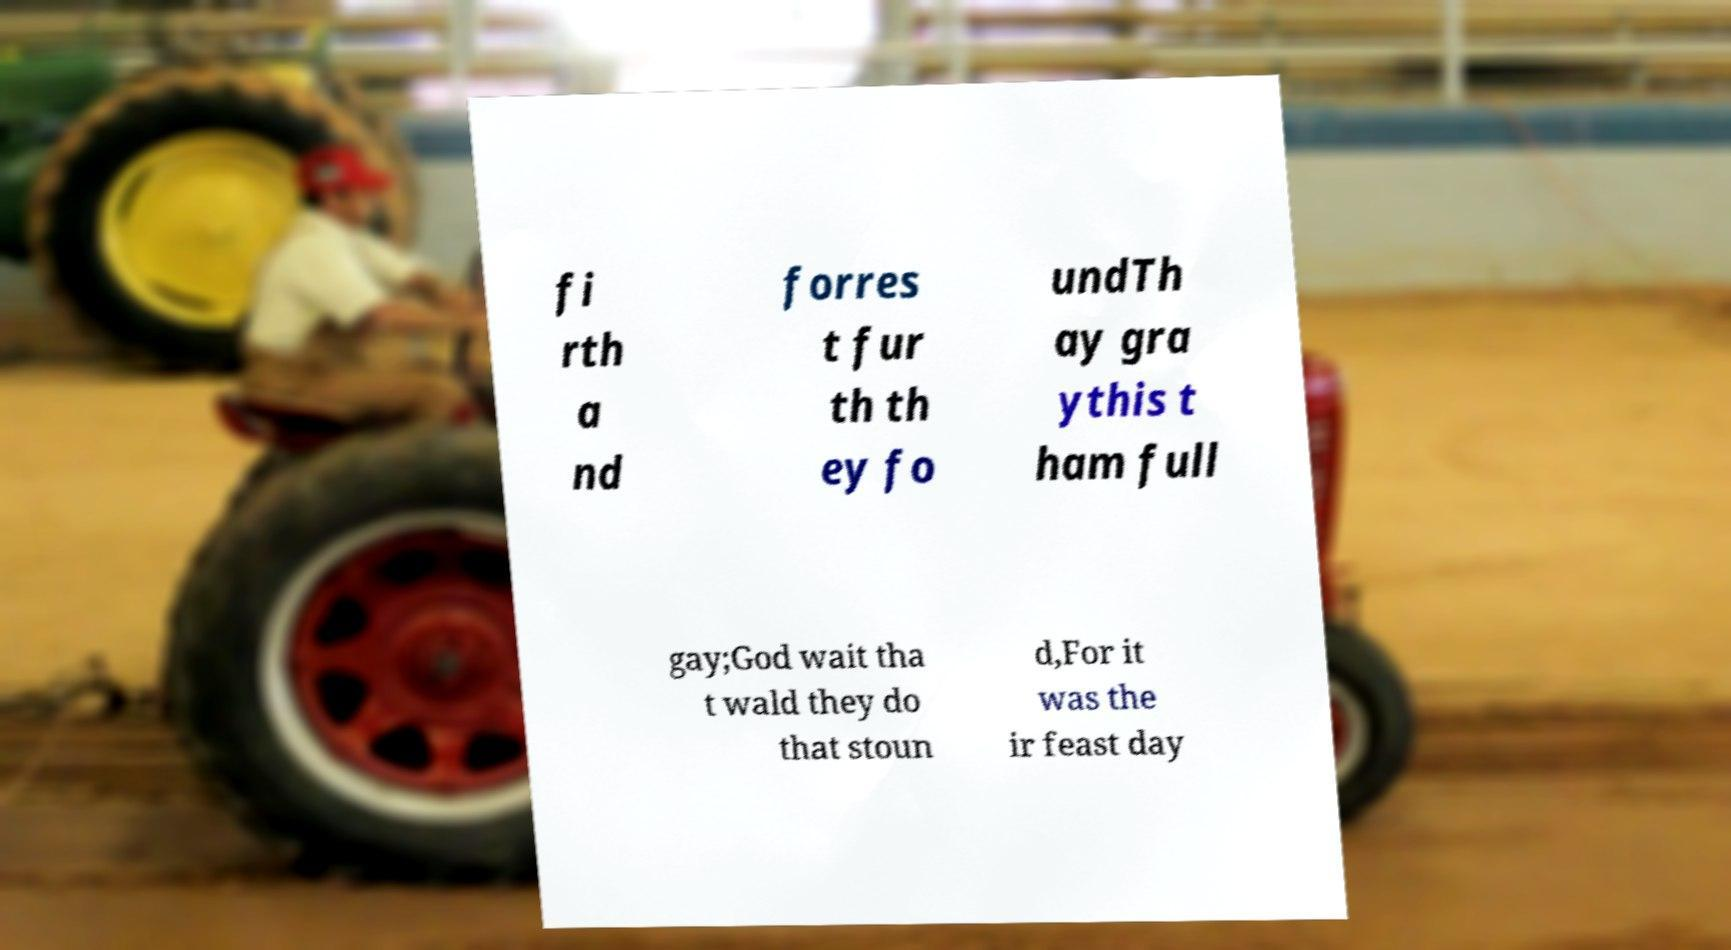For documentation purposes, I need the text within this image transcribed. Could you provide that? fi rth a nd forres t fur th th ey fo undTh ay gra ythis t ham full gay;God wait tha t wald they do that stoun d,For it was the ir feast day 